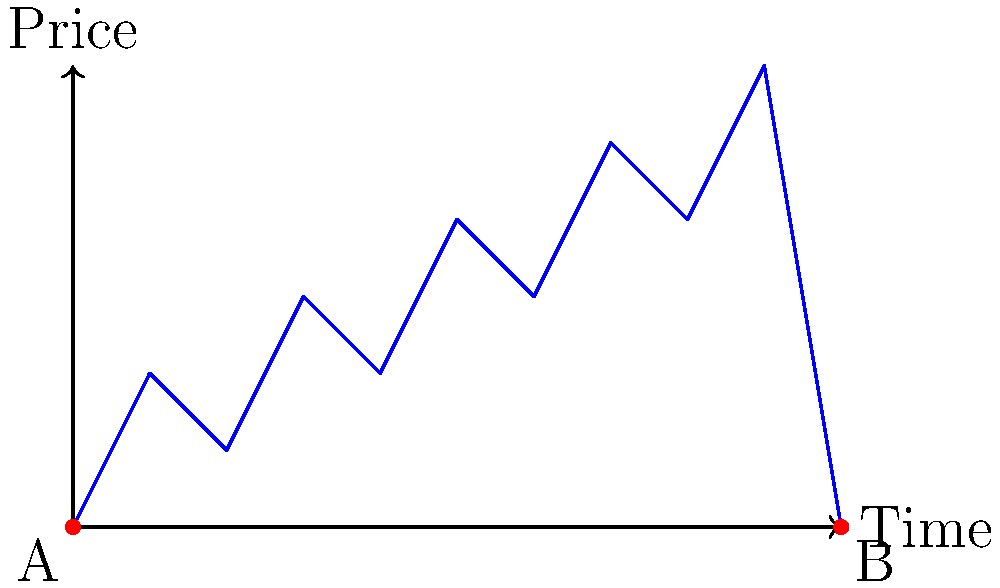A stock analyst has plotted the price movements of a particular stock over a 10-day period, resulting in the polygon shown above. If each unit on the horizontal axis represents one day and each unit on the vertical axis represents $100 in stock price, what is the total area under the stock price curve in dollar-days? To calculate the area under the stock price curve, we need to find the area of the polygon. We can do this by dividing the polygon into triangles and rectangles:

1. Divide the polygon into 10 vertical slices, each representing one day.
2. For each slice, calculate the area of a rectangle from the base to the lower point, then add the area of a triangle for the remaining portion.

Let's calculate slice by slice:

Day 1: Rectangle $(1 \times 0) + $ Triangle $\frac{1}{2} \times 1 \times 2 = 1$
Day 2: Rectangle $(1 \times 1) + $ Triangle $\frac{1}{2} \times 1 \times 0 = 1$
Day 3: Rectangle $(1 \times 1) + $ Triangle $\frac{1}{2} \times 1 \times 2 = 2$
Day 4: Rectangle $(1 \times 2) + $ Triangle $\frac{1}{2} \times 1 \times 0 = 2$
Day 5: Rectangle $(1 \times 2) + $ Triangle $\frac{1}{2} \times 1 \times 2 = 3$
Day 6: Rectangle $(1 \times 3) + $ Triangle $\frac{1}{2} \times 1 \times 0 = 3$
Day 7: Rectangle $(1 \times 3) + $ Triangle $\frac{1}{2} \times 1 \times 2 = 4$
Day 8: Rectangle $(1 \times 4) + $ Triangle $\frac{1}{2} \times 1 \times 0 = 4$
Day 9: Rectangle $(1 \times 4) + $ Triangle $\frac{1}{2} \times 1 \times 2 = 5$
Day 10: Rectangle $(1 \times 0) + $ Triangle $\frac{1}{2} \times 1 \times 6 = 3$

Total area = $1 + 1 + 2 + 2 + 3 + 3 + 4 + 4 + 5 + 3 = 28$ square units

Each unit represents $100 in stock price and 1 day, so:
Total area in dollar-days = $28 \times 100 = 2800$ dollar-days
Answer: $2800 dollar-days 